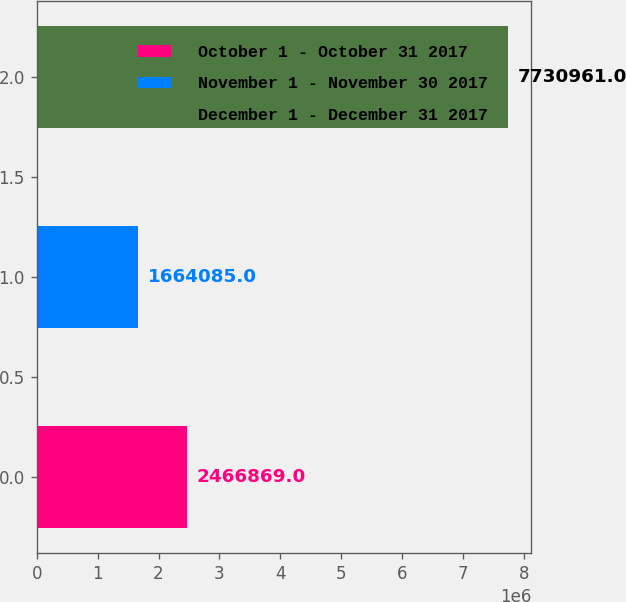Convert chart to OTSL. <chart><loc_0><loc_0><loc_500><loc_500><bar_chart><fcel>October 1 - October 31 2017<fcel>November 1 - November 30 2017<fcel>December 1 - December 31 2017<nl><fcel>2.46687e+06<fcel>1.66408e+06<fcel>7.73096e+06<nl></chart> 